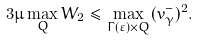<formula> <loc_0><loc_0><loc_500><loc_500>3 \mu \max _ { Q } W _ { 2 } \leq \max _ { \Gamma ( \varepsilon ) \times Q } ( v _ { \gamma } ^ { - } ) ^ { 2 } .</formula> 